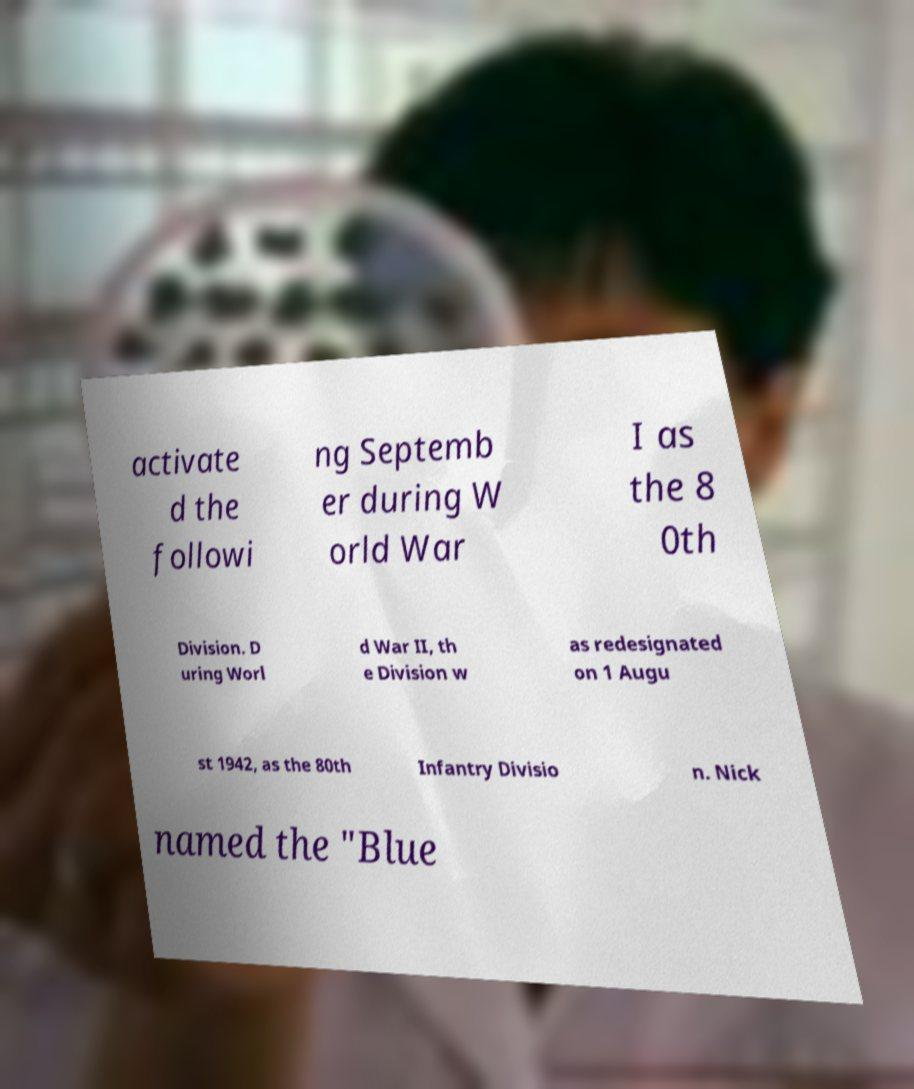Please read and relay the text visible in this image. What does it say? activate d the followi ng Septemb er during W orld War I as the 8 0th Division. D uring Worl d War II, th e Division w as redesignated on 1 Augu st 1942, as the 80th Infantry Divisio n. Nick named the "Blue 